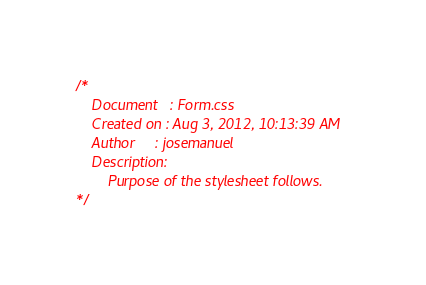<code> <loc_0><loc_0><loc_500><loc_500><_CSS_>/* 
    Document   : Form.css
    Created on : Aug 3, 2012, 10:13:39 AM
    Author     : josemanuel
    Description:
        Purpose of the stylesheet follows.
*/
</code> 